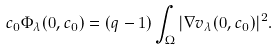Convert formula to latex. <formula><loc_0><loc_0><loc_500><loc_500>c _ { 0 } \Phi _ { \lambda } ( 0 , c _ { 0 } ) = ( q - 1 ) \int _ { \Omega } | \nabla v _ { \lambda } ( 0 , c _ { 0 } ) | ^ { 2 } .</formula> 